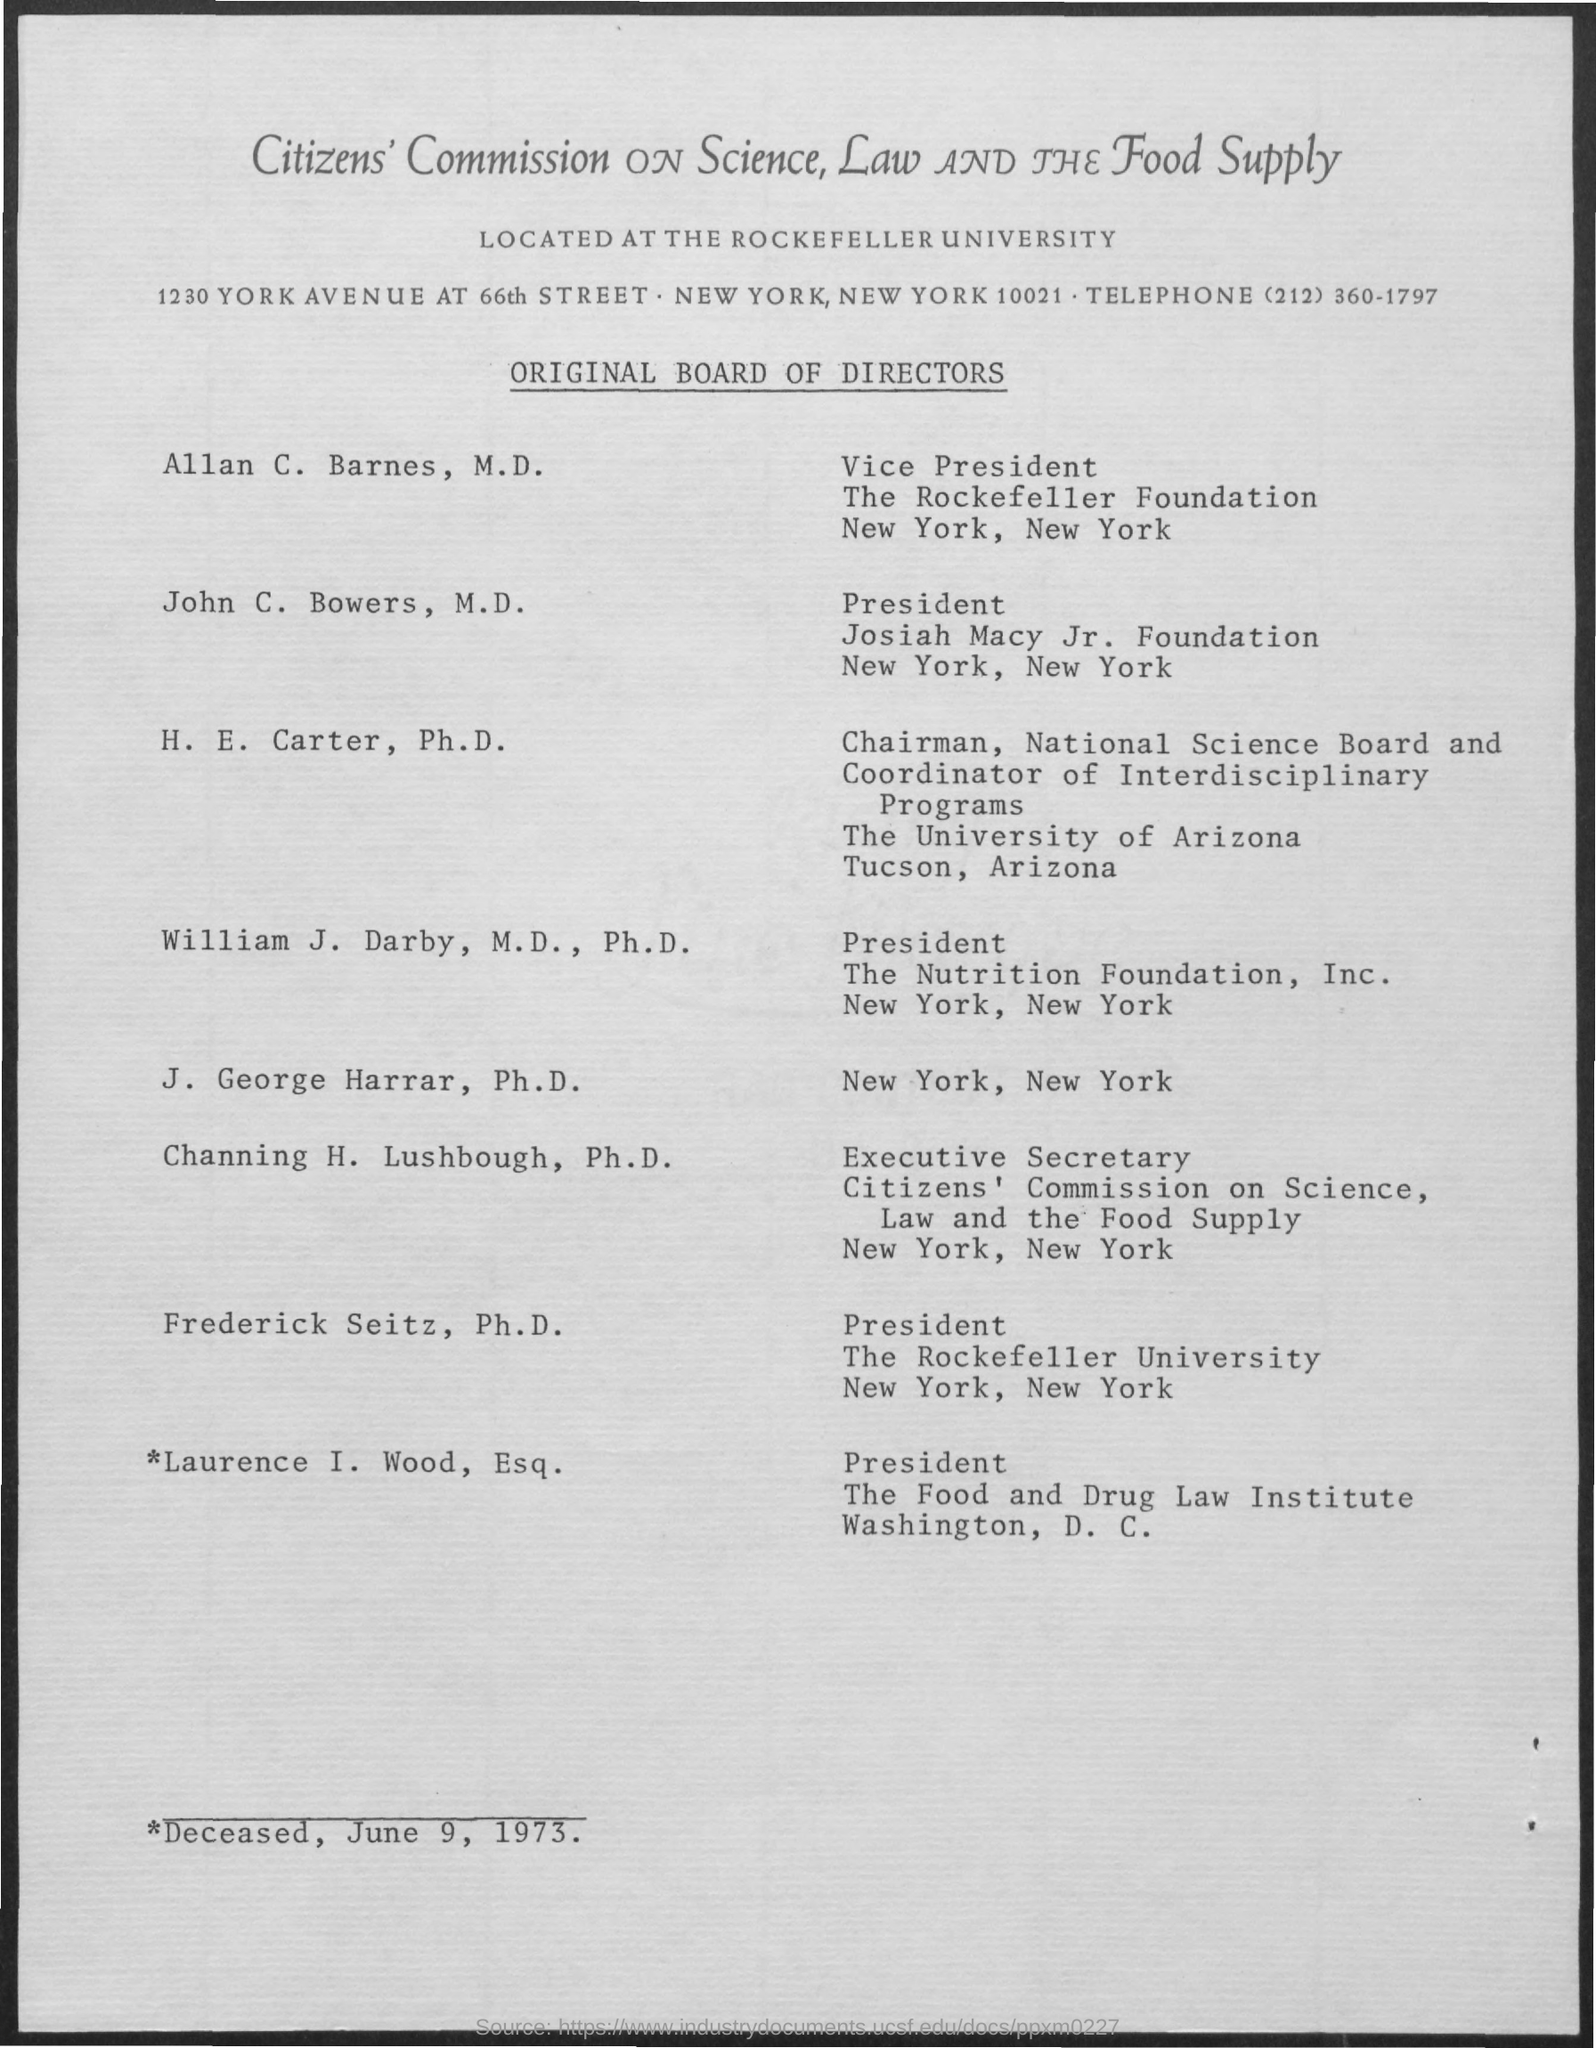What is the telephone no. mentioned in the given page ?
Provide a succinct answer. (212) 360-1797. What is the name of the vice president  for the rockefeller foundation?
Keep it short and to the point. Allan C. Barnes, M.D. 